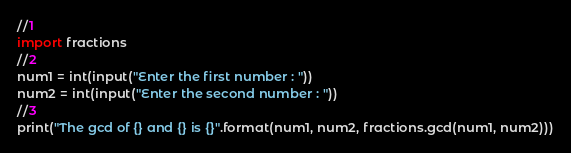<code> <loc_0><loc_0><loc_500><loc_500><_Python_>//1
import fractions
//2
num1 = int(input("Enter the first number : "))
num2 = int(input("Enter the second number : "))
//3
print("The gcd of {} and {} is {}".format(num1, num2, fractions.gcd(num1, num2)))
</code> 